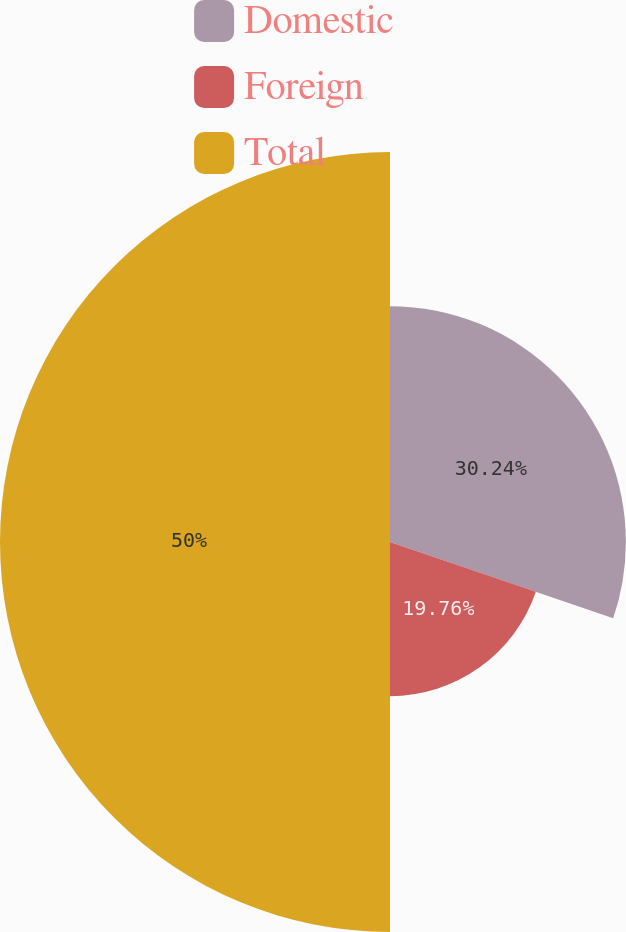Convert chart. <chart><loc_0><loc_0><loc_500><loc_500><pie_chart><fcel>Domestic<fcel>Foreign<fcel>Total<nl><fcel>30.24%<fcel>19.76%<fcel>50.0%<nl></chart> 